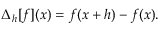<formula> <loc_0><loc_0><loc_500><loc_500>\Delta _ { h } [ f ] ( x ) = f ( x + h ) - f ( x ) .</formula> 